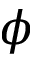Convert formula to latex. <formula><loc_0><loc_0><loc_500><loc_500>\phi</formula> 